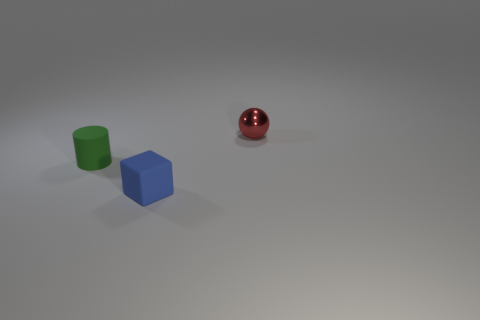Add 3 metal balls. How many objects exist? 6 Subtract all cubes. How many objects are left? 2 Subtract 0 purple cylinders. How many objects are left? 3 Subtract all rubber things. Subtract all blocks. How many objects are left? 0 Add 2 small red spheres. How many small red spheres are left? 3 Add 3 small red balls. How many small red balls exist? 4 